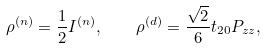Convert formula to latex. <formula><loc_0><loc_0><loc_500><loc_500>\rho ^ { ( n ) } = \frac { 1 } { 2 } I ^ { ( n ) } , \quad \rho ^ { ( d ) } = \frac { \sqrt { 2 } } { 6 } t _ { 2 0 } P _ { z z } ,</formula> 